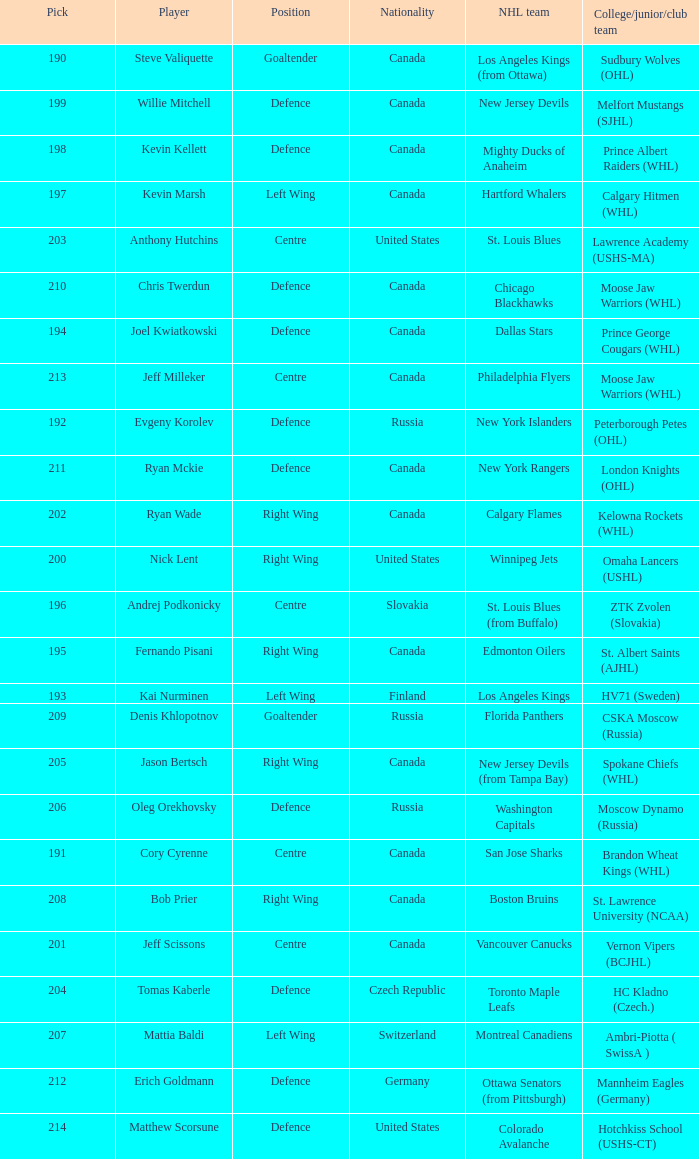Name the pick for matthew scorsune 214.0. 